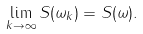Convert formula to latex. <formula><loc_0><loc_0><loc_500><loc_500>\lim _ { k \rightarrow \infty } S ( \omega _ { k } ) = S ( \omega ) .</formula> 